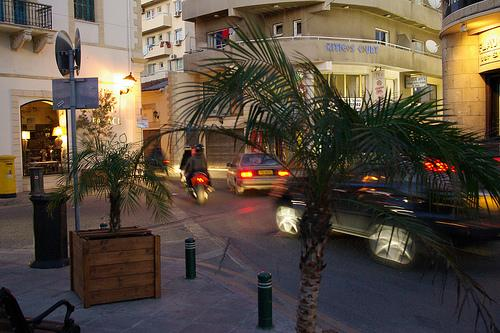Describe the scene happening on the road with the vehicles. There are two cars and a motorcycle on the road. One black car is passing by and a small grey car is driving, while a man rides the motorcycle down the street. Identify the primary mode of transportation shown in the image. A black car and a motorcycle are the main modes of transportation in the image. Count the total number of trees, including any that might be in planters. There are three trees in total, including two palm trees and one small tree in a wooden planter. What kind of tree is next to the road, and what are the characteristics of its leaves and trunk? There is a palm tree next to the road, with long green leaves, and a gray and brown trunk. Predict what the notable features in the image suggest about the overall sentiment or mood. The image depicts a busy urban street with various modes of transportation, suggesting a bustling and dynamic environment. How many people are on the motorcycle, and what color is the helmet of one person? There are two people on the motorcycle, and one is wearing a blue helmet. What is the color of the lettering on the building, and specify the color of the pole nearby. The lettering on the building is blue, and the nearby pole is green. Describe any objects on the sidewalk, including their colors and positions. Some objects on the sidewalk include a small palm tree, a wooden box with a plant in it, a yellow trash can, and a wooden crate. Find the ice cream vendor and tell me which flavors are available. No, it's not mentioned in the image. 